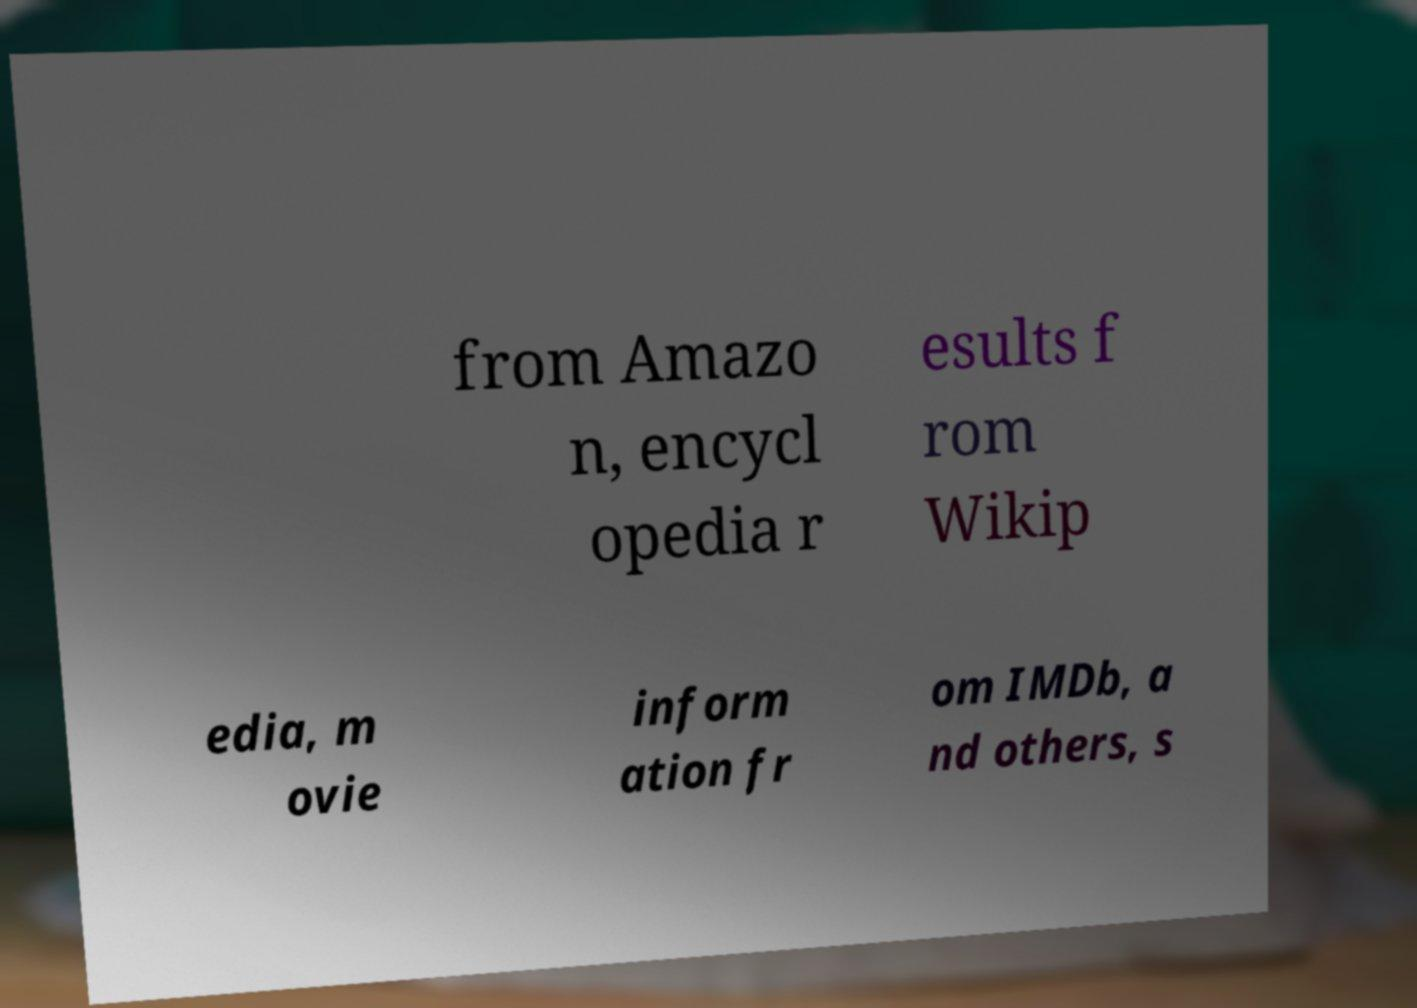Can you accurately transcribe the text from the provided image for me? from Amazo n, encycl opedia r esults f rom Wikip edia, m ovie inform ation fr om IMDb, a nd others, s 